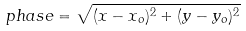<formula> <loc_0><loc_0><loc_500><loc_500>p h a s e = \sqrt { ( x - x _ { o } ) ^ { 2 } + ( y - y _ { o } ) ^ { 2 } }</formula> 